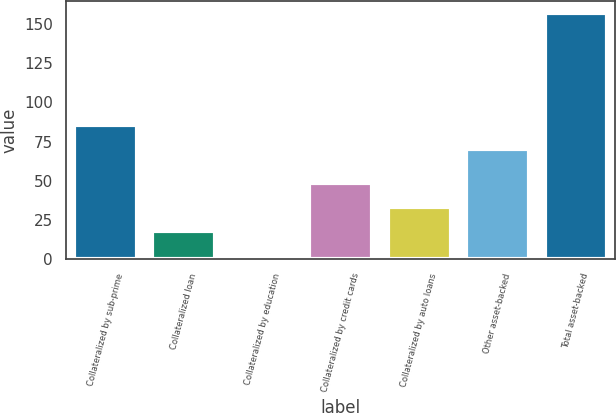Convert chart to OTSL. <chart><loc_0><loc_0><loc_500><loc_500><bar_chart><fcel>Collateralized by sub-prime<fcel>Collateralized loan<fcel>Collateralized by education<fcel>Collateralized by credit cards<fcel>Collateralized by auto loans<fcel>Other asset-backed<fcel>Total asset-backed<nl><fcel>85.46<fcel>17.85<fcel>2.39<fcel>48.77<fcel>33.31<fcel>70<fcel>157<nl></chart> 